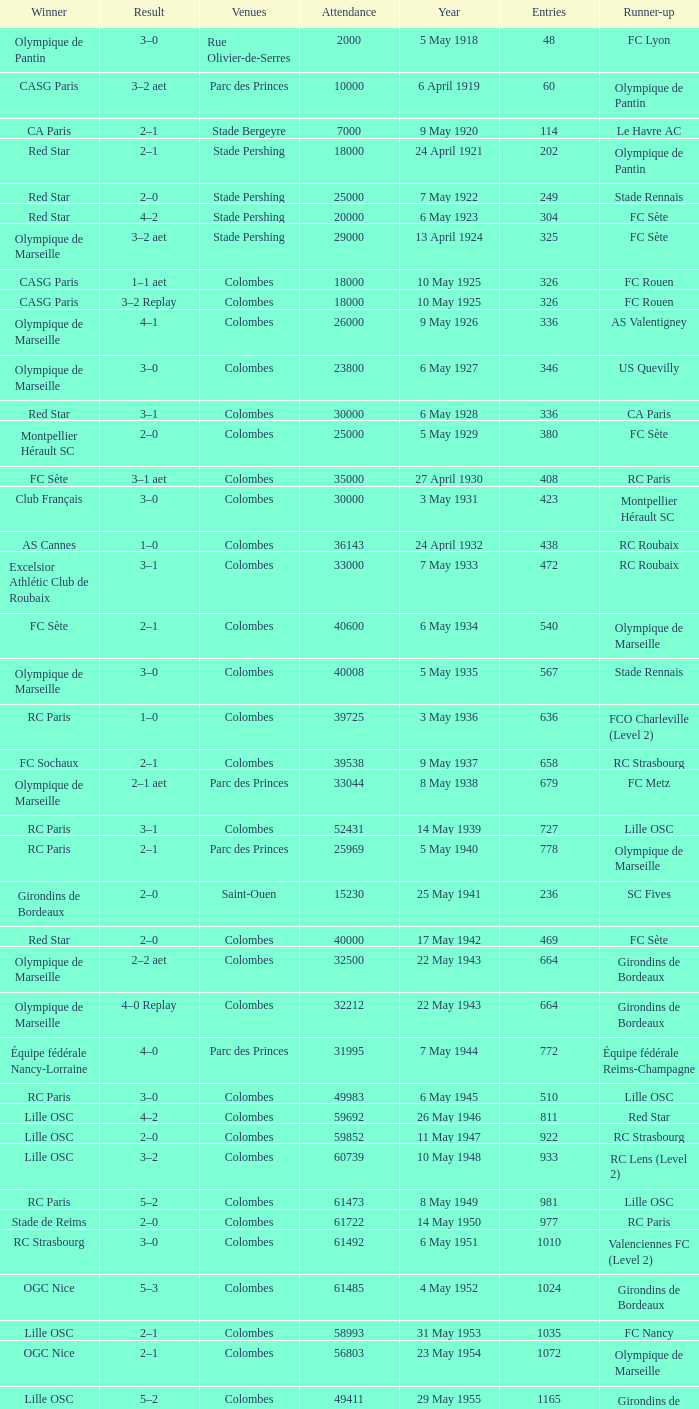How many games had red star as the runner up? 1.0. 